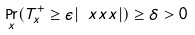<formula> <loc_0><loc_0><loc_500><loc_500>\Pr _ { x } ( T ^ { + } _ { x } \geq \epsilon | \ x x x | ) \geq \delta > 0</formula> 